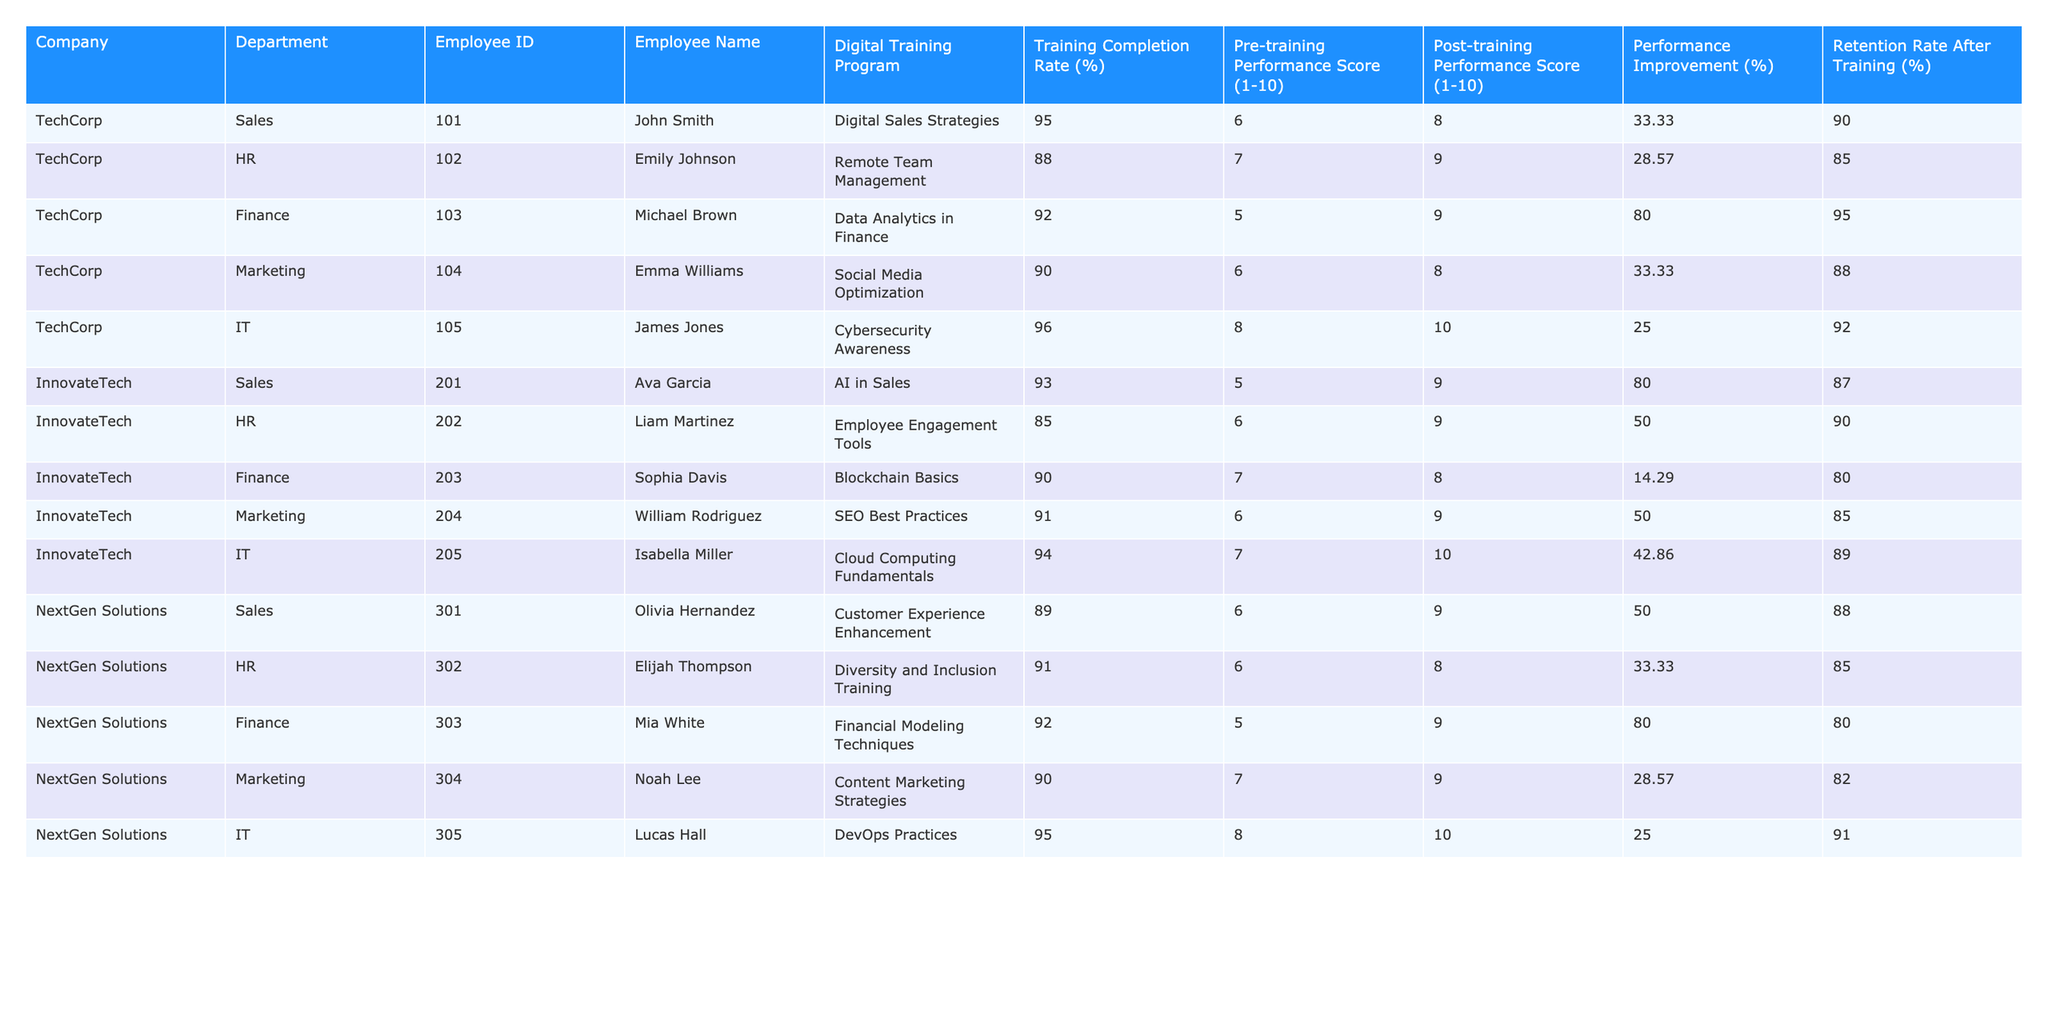What is the highest post-training performance score among the employees? The post-training performance scores are as follows: John Smith (8), Emily Johnson (9), Michael Brown (9), Emma Williams (8), James Jones (10), Ava Garcia (9), Liam Martinez (9), Sophia Davis (8), William Rodriguez (9), Isabella Miller (10), Olivia Hernandez (9), Elijah Thompson (8), Mia White (9), Noah Lee (9), Lucas Hall (10). The highest score is 10, achieved by James Jones, Isabella Miller, and Lucas Hall.
Answer: 10 Which department had the lowest average performance improvement percentage? The performance improvement percentages for each department are as follows: Sales (50.00%), HR (39.29%), Finance (64.29%), Marketing (33.33%), IT (25.00%). Summing these values gives us 50 + 39.29 + 64.29 + 33.33 + 25 = 212.61, and there are 5 departments, making the average 212.61/5 = 42.52%. The department with the lowest average is IT (25.00%).
Answer: IT Did any employee have a retention rate lower than 85%? Reviewing the retention rates: John Smith (90%), Emily Johnson (85%), Michael Brown (95%), Emma Williams (88%), James Jones (92%), Ava Garcia (87%), Liam Martinez (90%), Sophia Davis (80%), William Rodriguez (85%), Isabella Miller (89%), Olivia Hernandez (88%), Elijah Thompson (85%), Mia White (80%), Noah Lee (82%), Lucas Hall (91%). Sophia Davis and Mia White both have retention rates lower than 85%.
Answer: Yes What is the overall retention rate for the Finance department? The retention rates for the Finance department employees are: Michael Brown (95%), Sophia Davis (80%), and Mia White (80%). Summing these gives 95 + 80 + 80 = 255. Dividing by the number of employees in Finance (3) gives 255/3 = 85%.
Answer: 85% Which employee experienced the highest performance improvement percentage? The performance improvement percentages are: John Smith (33.33%), Emily Johnson (28.57%), Michael Brown (80.00%), Emma Williams (33.33%), James Jones (25.00%), Ava Garcia (80.00%), Liam Martinez (50.00%), Sophia Davis (14.29%), William Rodriguez (50.00%), Isabella Miller (42.86%), Olivia Hernandez (50.00%), Elijah Thompson (33.33%), Mia White (80.00%), Noah Lee (28.57%), Lucas Hall (25.00%). Michael Brown, Ava Garcia, and Mia White all show the highest improvement of 80.00%.
Answer: Michael Brown, Ava Garcia, and Mia White What is the relationship between the training completion rate and performance improvement percentage across all employees? By assessing the training completion rates and their corresponding performance improvements, we see a range where higher completion rates (like James Jones at 96% and performance improvement of 25%) don’t correlate directly with high improvements. The highest improvement (80% by Michael Brown) correlates but does not have the highest completion rate. Thus, the relationship appears inconsistent.
Answer: Inconsistent Which digital training program had the highest training completion rate? The training completion rates are: Digital Sales Strategies (95%), Remote Team Management (88%), Data Analytics in Finance (92%), Social Media Optimization (90%), Cybersecurity Awareness (96%), AI in Sales (93%), Employee Engagement Tools (85%), Blockchain Basics (90%), SEO Best Practices (91%), Cloud Computing Fundamentals (94%), Customer Experience Enhancement (89%), Diversity and Inclusion Training (91%), Financial Modeling Techniques (92%), Content Marketing Strategies (90%), DevOps Practices (95%). Cybersecurity Awareness has the highest rate at 96%.
Answer: Cybersecurity Awareness What is the average training completion rate for employees in the HR department? The training completion rates for the HR department are: Emily Johnson (88%), Liam Martinez (85%), and Elijah Thompson (91%). Summing these gives 88 + 85 + 91 = 264. Dividing by the number of HR employees (3) gives an average of 264/3 ≈ 88%.
Answer: 88% 